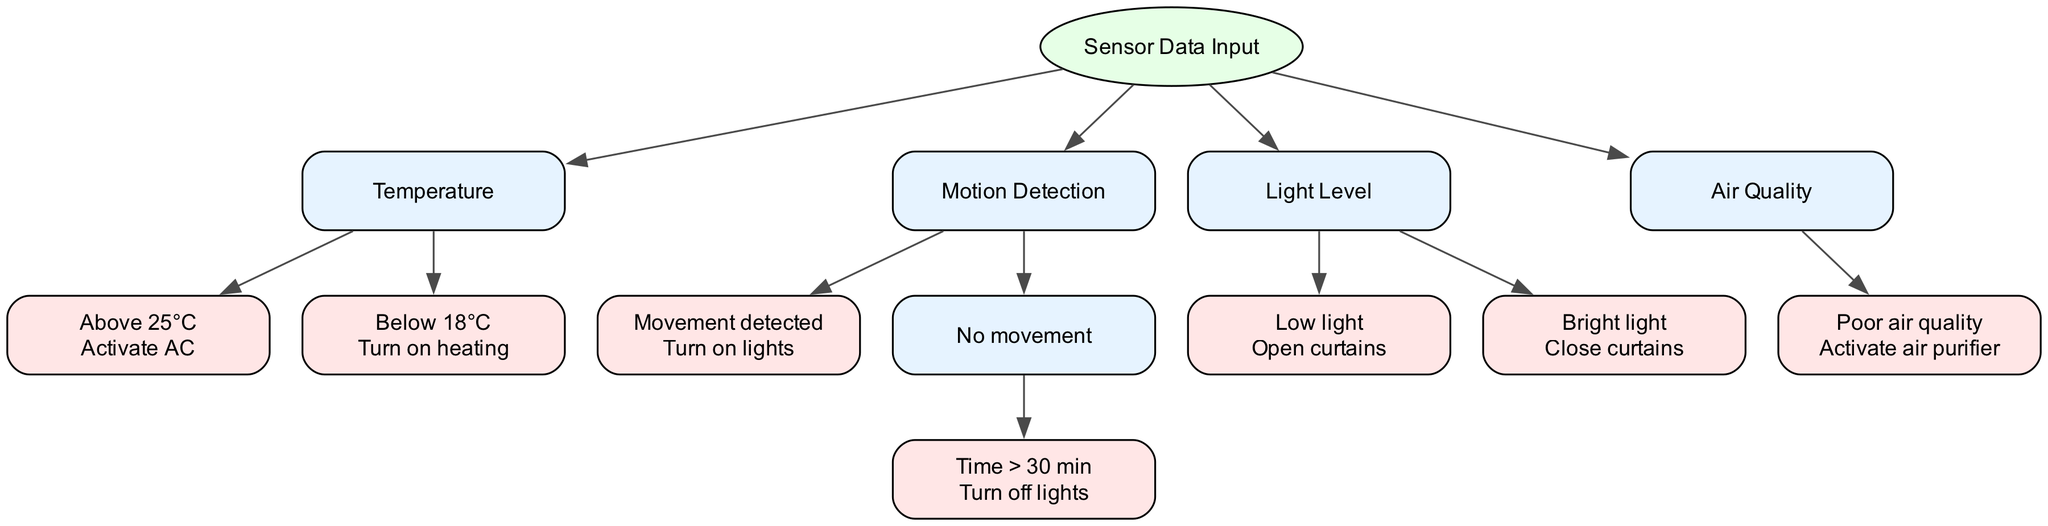What is the root node of the decision tree? The root node of the decision tree is "Sensor Data Input". This is identified as the starting point of the diagram, indicated by its position at the top and the absence of any incoming edges.
Answer: Sensor Data Input How many actions are associated with the "Temperature" node? The "Temperature" node has two associated actions: "Activate AC" for temperatures above 25°C and "Turn on heating" for temperatures below 18°C. This can be observed by counting the children of the "Temperature" node.
Answer: 2 What action is taken if poor air quality is detected? If poor air quality is detected, the action is to "Activate air purifier". This is found at the end of the flow for the "Air Quality" node.
Answer: Activate air purifier What happens if no movement is detected for more than 30 minutes? If no movement is detected for more than 30 minutes, the action taken is "Turn off lights". This is obtained by following the condition in the "Motion Detection" node, specifically analyzing the child condition of "No movement".
Answer: Turn off lights Which node will result in opening curtains? The node that results in opening curtains corresponds to the "Light Level" node, specifically when the condition is "Low light". This is derived from the children of the "Light Level" node where it explicitly states the action.
Answer: Open curtains How many total child nodes does the "Motion Detection" node have? The "Motion Detection" node has two child nodes: one for "Movement detected" and another for "No movement". The presence of these two conditions can be verified by examining the children of the "Motion Detection" node.
Answer: 2 What is the action for a temperature reading below 18°C? The action for a temperature reading below 18°C is to "Turn on heating". This action can be traced directly from the corresponding child of the "Temperature" node.
Answer: Turn on heating What happens when light levels are bright? When light levels are bright, the action taken is to "Close curtains". This outcome is found by locating the child condition of the "Light Level" node labeled as "Bright light".
Answer: Close curtains 